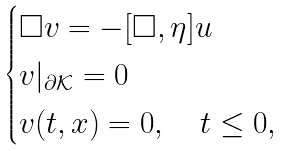<formula> <loc_0><loc_0><loc_500><loc_500>\begin{cases} \Box v = - [ \Box , \eta ] u \\ v | _ { \partial \mathcal { K } } = 0 \\ v ( t , x ) = 0 , \quad t \leq 0 , \end{cases}</formula> 